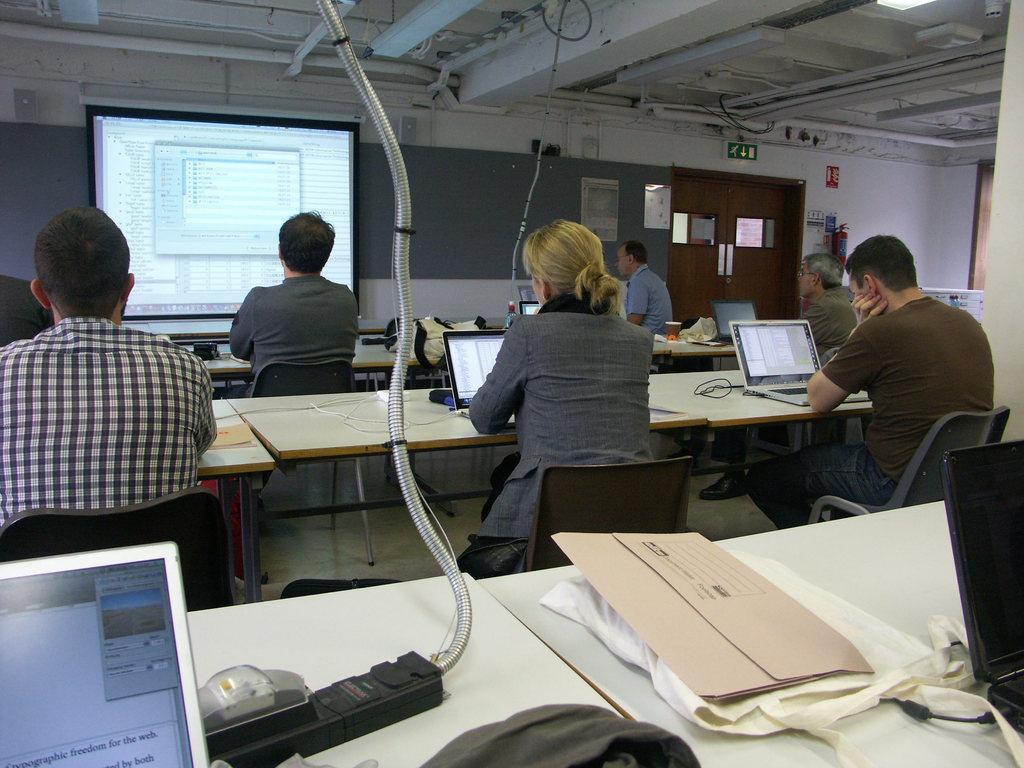Could you give a brief overview of what you see in this image? In this picture we can see a few people sitting on the chair. There are laptops, wires, bags, switchboard and other objects are visible on the tables. We can see some text on a projector screen. There is a poster, red color cylinder, signs on a green board and a few things visible the wall. We can see a door and door handles in the background. There are few pipes and a light is visible on top. 